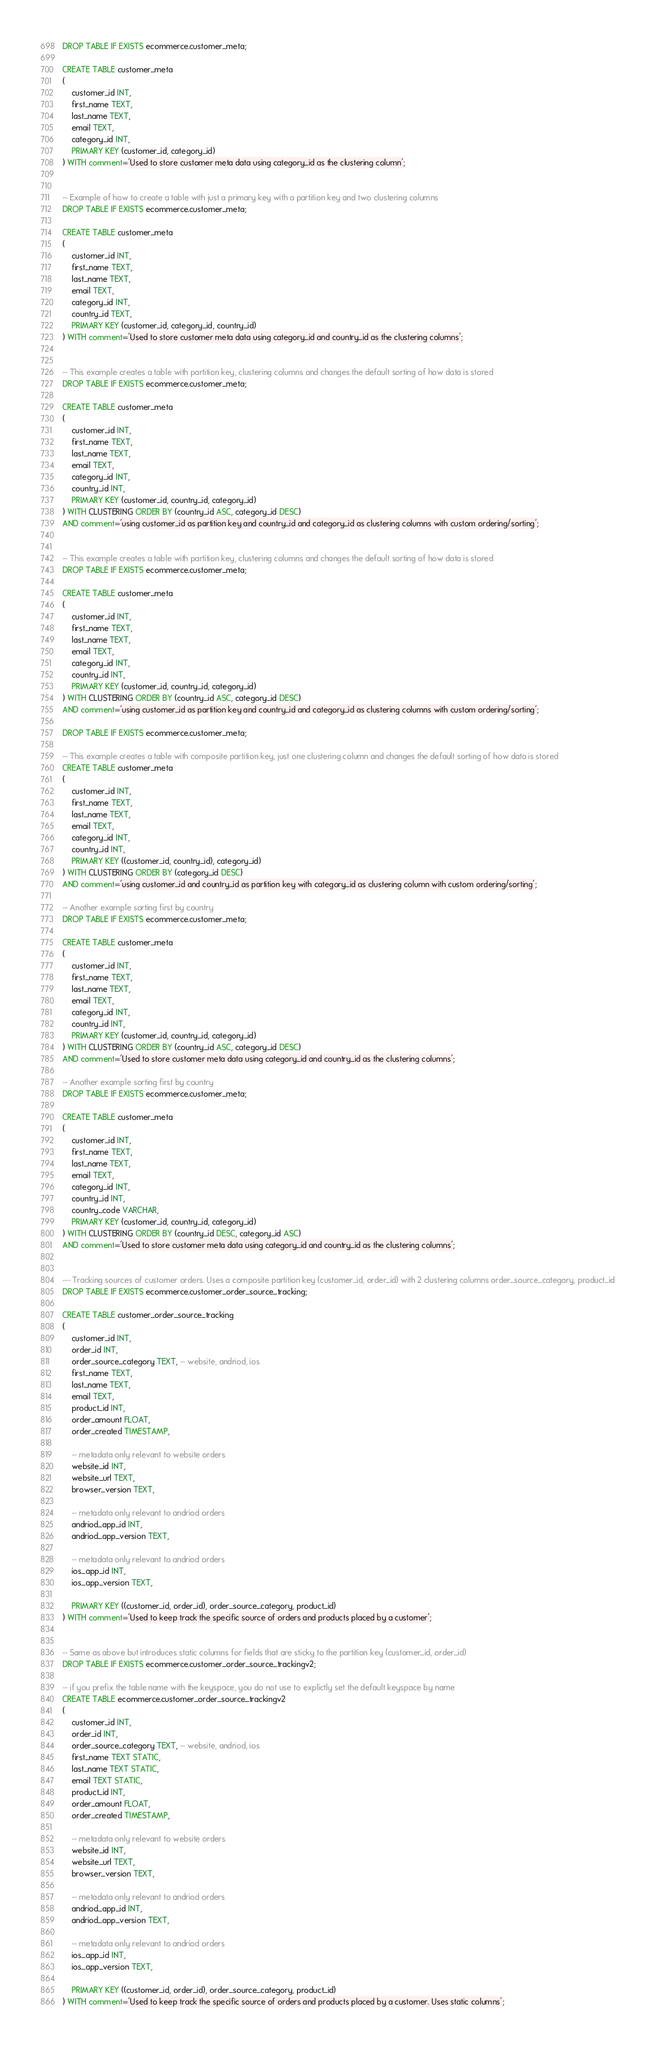Convert code to text. <code><loc_0><loc_0><loc_500><loc_500><_SQL_>DROP TABLE IF EXISTS ecommerce.customer_meta;

CREATE TABLE customer_meta
(
    customer_id INT,
    first_name TEXT,
    last_name TEXT,
    email TEXT,
    category_id INT,
    PRIMARY KEY (customer_id, category_id)
) WITH comment='Used to store customer meta data using category_id as the clustering column';


-- Example of how to create a table with just a primary key with a partition key and two clustering columns
DROP TABLE IF EXISTS ecommerce.customer_meta;

CREATE TABLE customer_meta
(
    customer_id INT,
    first_name TEXT,
    last_name TEXT,
    email TEXT,
    category_id INT,
    country_id TEXT,
    PRIMARY KEY (customer_id, category_id, country_id)
) WITH comment='Used to store customer meta data using category_id and country_id as the clustering columns';


-- This example creates a table with partition key, clustering columns and changes the default sorting of how data is stored
DROP TABLE IF EXISTS ecommerce.customer_meta;

CREATE TABLE customer_meta
(
    customer_id INT,
    first_name TEXT,
    last_name TEXT,
    email TEXT,
    category_id INT,
    country_id INT,
    PRIMARY KEY (customer_id, country_id, category_id)
) WITH CLUSTERING ORDER BY (country_id ASC, category_id DESC) 
AND comment='using customer_id as partition key and country_id and category_id as clustering columns with custom ordering/sorting';


-- This example creates a table with partition key, clustering columns and changes the default sorting of how data is stored
DROP TABLE IF EXISTS ecommerce.customer_meta;

CREATE TABLE customer_meta
(
    customer_id INT,
    first_name TEXT,
    last_name TEXT,
    email TEXT,
    category_id INT,
    country_id INT,
    PRIMARY KEY (customer_id, country_id, category_id)
) WITH CLUSTERING ORDER BY (country_id ASC, category_id DESC) 
AND comment='using customer_id as partition key and country_id and category_id as clustering columns with custom ordering/sorting';

DROP TABLE IF EXISTS ecommerce.customer_meta;

-- This example creates a table with composite partition key, just one clustering column and changes the default sorting of how data is stored
CREATE TABLE customer_meta
(
    customer_id INT,
    first_name TEXT,
    last_name TEXT,
    email TEXT,
    category_id INT,
    country_id INT,
    PRIMARY KEY ((customer_id, country_id), category_id)
) WITH CLUSTERING ORDER BY (category_id DESC) 
AND comment='using customer_id and country_id as partition key with category_id as clustering column with custom ordering/sorting';

-- Another example sorting first by country
DROP TABLE IF EXISTS ecommerce.customer_meta;

CREATE TABLE customer_meta
(
    customer_id INT,
    first_name TEXT,
    last_name TEXT,
    email TEXT,
    category_id INT,
    country_id INT,
    PRIMARY KEY (customer_id, country_id, category_id)
) WITH CLUSTERING ORDER BY (country_id ASC, category_id DESC) 
AND comment='Used to store customer meta data using category_id and country_id as the clustering columns';

-- Another example sorting first by country
DROP TABLE IF EXISTS ecommerce.customer_meta;

CREATE TABLE customer_meta
(
    customer_id INT,
    first_name TEXT,
    last_name TEXT,
    email TEXT,
    category_id INT,
    country_id INT,
    country_code VARCHAR,
    PRIMARY KEY (customer_id, country_id, category_id)
) WITH CLUSTERING ORDER BY (country_id DESC, category_id ASC) 
AND comment='Used to store customer meta data using category_id and country_id as the clustering columns';


--- Tracking sources of customer orders. Uses a composite partition key (customer_id, order_id) with 2 clustering columns order_source_category, product_id
DROP TABLE IF EXISTS ecommerce.customer_order_source_tracking;

CREATE TABLE customer_order_source_tracking
(
    customer_id INT,
    order_id INT,
    order_source_category TEXT, -- website, andriod, ios
    first_name TEXT,
    last_name TEXT,
    email TEXT,
    product_id INT,
    order_amount FLOAT,
    order_created TIMESTAMP,

    -- metadata only relevant to website orders
    website_id INT,
    website_url TEXT,
    browser_version TEXT,

    -- metadata only relevant to andriod orders
    andriod_app_id INT,
    andriod_app_version TEXT,

    -- metadata only relevant to andriod orders
    ios_app_id INT,
    ios_app_version TEXT,

    PRIMARY KEY ((customer_id, order_id), order_source_category, product_id)
) WITH comment='Used to keep track the specific source of orders and products placed by a customer';


-- Same as above but introduces static columns for fields that are sticky to the partition key (customer_id, order_id)
DROP TABLE IF EXISTS ecommerce.customer_order_source_trackingv2;

-- if you prefix the table name with the keyspace, you do not use to explictly set the default keyspace by name
CREATE TABLE ecommerce.customer_order_source_trackingv2
(
    customer_id INT,
    order_id INT,
    order_source_category TEXT, -- website, andriod, ios
    first_name TEXT STATIC,
    last_name TEXT STATIC,
    email TEXT STATIC,
    product_id INT,
    order_amount FLOAT,
    order_created TIMESTAMP,

    -- metadata only relevant to website orders
    website_id INT,
    website_url TEXT,
    browser_version TEXT,

    -- metadata only relevant to andriod orders
    andriod_app_id INT,
    andriod_app_version TEXT,

    -- metadata only relevant to andriod orders
    ios_app_id INT,
    ios_app_version TEXT,

    PRIMARY KEY ((customer_id, order_id), order_source_category, product_id)
) WITH comment='Used to keep track the specific source of orders and products placed by a customer. Uses static columns';
</code> 